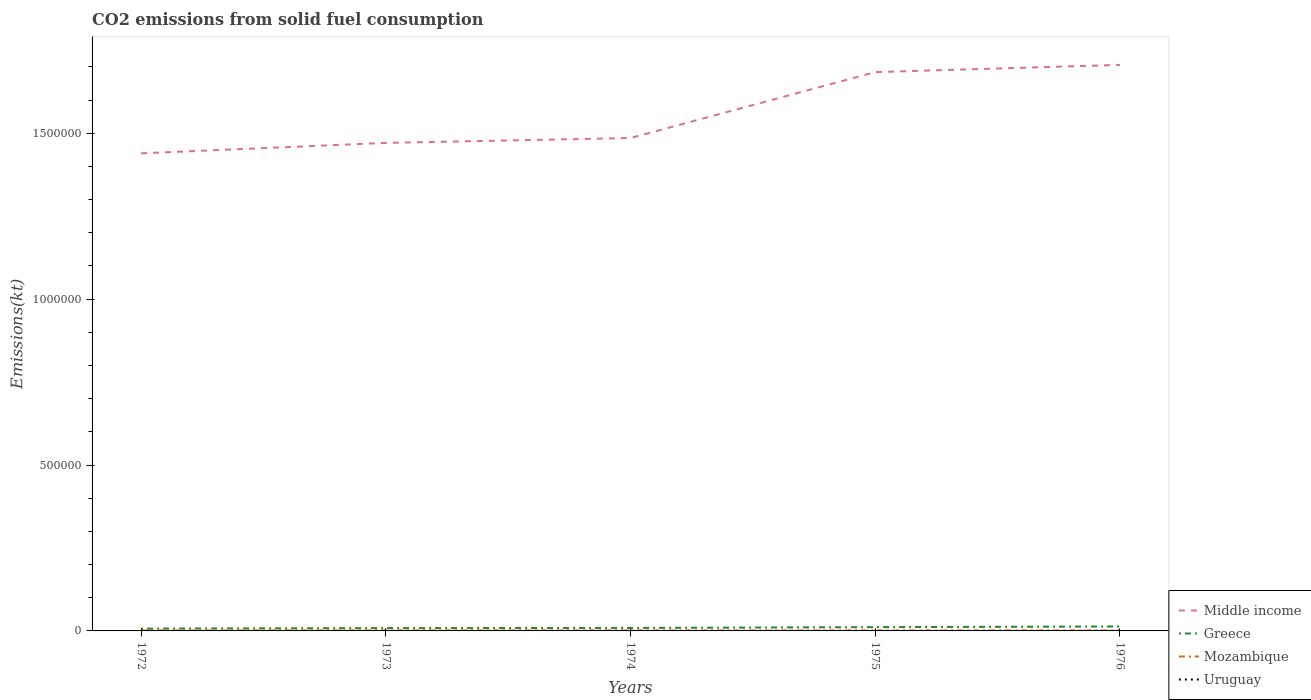Does the line corresponding to Middle income intersect with the line corresponding to Mozambique?
Give a very brief answer. No. Is the number of lines equal to the number of legend labels?
Give a very brief answer. Yes. Across all years, what is the maximum amount of CO2 emitted in Middle income?
Your answer should be very brief. 1.44e+06. In which year was the amount of CO2 emitted in Uruguay maximum?
Offer a very short reply. 1976. What is the total amount of CO2 emitted in Uruguay in the graph?
Ensure brevity in your answer.  11. What is the difference between the highest and the second highest amount of CO2 emitted in Mozambique?
Offer a terse response. 234.69. Is the amount of CO2 emitted in Middle income strictly greater than the amount of CO2 emitted in Uruguay over the years?
Ensure brevity in your answer.  No. How many lines are there?
Ensure brevity in your answer.  4. What is the difference between two consecutive major ticks on the Y-axis?
Give a very brief answer. 5.00e+05. Are the values on the major ticks of Y-axis written in scientific E-notation?
Provide a succinct answer. No. What is the title of the graph?
Keep it short and to the point. CO2 emissions from solid fuel consumption. Does "Denmark" appear as one of the legend labels in the graph?
Provide a short and direct response. No. What is the label or title of the X-axis?
Offer a terse response. Years. What is the label or title of the Y-axis?
Provide a short and direct response. Emissions(kt). What is the Emissions(kt) in Middle income in 1972?
Provide a succinct answer. 1.44e+06. What is the Emissions(kt) in Greece in 1972?
Your answer should be very brief. 6970.97. What is the Emissions(kt) in Mozambique in 1972?
Make the answer very short. 1426.46. What is the Emissions(kt) in Uruguay in 1972?
Your answer should be very brief. 88.01. What is the Emissions(kt) in Middle income in 1973?
Offer a terse response. 1.47e+06. What is the Emissions(kt) of Greece in 1973?
Offer a very short reply. 8500.11. What is the Emissions(kt) in Mozambique in 1973?
Provide a succinct answer. 1558.47. What is the Emissions(kt) of Uruguay in 1973?
Your answer should be very brief. 73.34. What is the Emissions(kt) in Middle income in 1974?
Give a very brief answer. 1.49e+06. What is the Emissions(kt) of Greece in 1974?
Your answer should be compact. 8998.82. What is the Emissions(kt) in Mozambique in 1974?
Keep it short and to the point. 1496.14. What is the Emissions(kt) in Uruguay in 1974?
Your response must be concise. 77.01. What is the Emissions(kt) in Middle income in 1975?
Offer a very short reply. 1.68e+06. What is the Emissions(kt) in Greece in 1975?
Your answer should be very brief. 1.14e+04. What is the Emissions(kt) in Mozambique in 1975?
Give a very brief answer. 1371.46. What is the Emissions(kt) in Uruguay in 1975?
Your answer should be compact. 77.01. What is the Emissions(kt) of Middle income in 1976?
Give a very brief answer. 1.71e+06. What is the Emissions(kt) of Greece in 1976?
Provide a short and direct response. 1.34e+04. What is the Emissions(kt) of Mozambique in 1976?
Your response must be concise. 1323.79. What is the Emissions(kt) in Uruguay in 1976?
Offer a very short reply. 69.67. Across all years, what is the maximum Emissions(kt) in Middle income?
Your answer should be very brief. 1.71e+06. Across all years, what is the maximum Emissions(kt) of Greece?
Provide a succinct answer. 1.34e+04. Across all years, what is the maximum Emissions(kt) of Mozambique?
Provide a succinct answer. 1558.47. Across all years, what is the maximum Emissions(kt) in Uruguay?
Give a very brief answer. 88.01. Across all years, what is the minimum Emissions(kt) in Middle income?
Offer a very short reply. 1.44e+06. Across all years, what is the minimum Emissions(kt) of Greece?
Keep it short and to the point. 6970.97. Across all years, what is the minimum Emissions(kt) in Mozambique?
Ensure brevity in your answer.  1323.79. Across all years, what is the minimum Emissions(kt) of Uruguay?
Your answer should be very brief. 69.67. What is the total Emissions(kt) in Middle income in the graph?
Your response must be concise. 7.79e+06. What is the total Emissions(kt) in Greece in the graph?
Your response must be concise. 4.92e+04. What is the total Emissions(kt) in Mozambique in the graph?
Make the answer very short. 7176.32. What is the total Emissions(kt) of Uruguay in the graph?
Provide a succinct answer. 385.04. What is the difference between the Emissions(kt) in Middle income in 1972 and that in 1973?
Ensure brevity in your answer.  -3.15e+04. What is the difference between the Emissions(kt) of Greece in 1972 and that in 1973?
Make the answer very short. -1529.14. What is the difference between the Emissions(kt) of Mozambique in 1972 and that in 1973?
Offer a very short reply. -132.01. What is the difference between the Emissions(kt) in Uruguay in 1972 and that in 1973?
Offer a terse response. 14.67. What is the difference between the Emissions(kt) of Middle income in 1972 and that in 1974?
Your answer should be compact. -4.62e+04. What is the difference between the Emissions(kt) of Greece in 1972 and that in 1974?
Give a very brief answer. -2027.85. What is the difference between the Emissions(kt) of Mozambique in 1972 and that in 1974?
Keep it short and to the point. -69.67. What is the difference between the Emissions(kt) in Uruguay in 1972 and that in 1974?
Offer a very short reply. 11. What is the difference between the Emissions(kt) in Middle income in 1972 and that in 1975?
Keep it short and to the point. -2.45e+05. What is the difference between the Emissions(kt) of Greece in 1972 and that in 1975?
Your response must be concise. -4393.07. What is the difference between the Emissions(kt) of Mozambique in 1972 and that in 1975?
Keep it short and to the point. 55.01. What is the difference between the Emissions(kt) of Uruguay in 1972 and that in 1975?
Your answer should be very brief. 11. What is the difference between the Emissions(kt) in Middle income in 1972 and that in 1976?
Give a very brief answer. -2.67e+05. What is the difference between the Emissions(kt) in Greece in 1972 and that in 1976?
Offer a very short reply. -6442.92. What is the difference between the Emissions(kt) in Mozambique in 1972 and that in 1976?
Give a very brief answer. 102.68. What is the difference between the Emissions(kt) of Uruguay in 1972 and that in 1976?
Provide a short and direct response. 18.34. What is the difference between the Emissions(kt) in Middle income in 1973 and that in 1974?
Give a very brief answer. -1.47e+04. What is the difference between the Emissions(kt) of Greece in 1973 and that in 1974?
Your answer should be compact. -498.71. What is the difference between the Emissions(kt) in Mozambique in 1973 and that in 1974?
Make the answer very short. 62.34. What is the difference between the Emissions(kt) in Uruguay in 1973 and that in 1974?
Make the answer very short. -3.67. What is the difference between the Emissions(kt) of Middle income in 1973 and that in 1975?
Keep it short and to the point. -2.13e+05. What is the difference between the Emissions(kt) of Greece in 1973 and that in 1975?
Your answer should be compact. -2863.93. What is the difference between the Emissions(kt) in Mozambique in 1973 and that in 1975?
Ensure brevity in your answer.  187.02. What is the difference between the Emissions(kt) in Uruguay in 1973 and that in 1975?
Your answer should be compact. -3.67. What is the difference between the Emissions(kt) of Middle income in 1973 and that in 1976?
Your answer should be compact. -2.35e+05. What is the difference between the Emissions(kt) in Greece in 1973 and that in 1976?
Provide a short and direct response. -4913.78. What is the difference between the Emissions(kt) of Mozambique in 1973 and that in 1976?
Your answer should be compact. 234.69. What is the difference between the Emissions(kt) of Uruguay in 1973 and that in 1976?
Offer a very short reply. 3.67. What is the difference between the Emissions(kt) of Middle income in 1974 and that in 1975?
Make the answer very short. -1.99e+05. What is the difference between the Emissions(kt) in Greece in 1974 and that in 1975?
Provide a short and direct response. -2365.22. What is the difference between the Emissions(kt) in Mozambique in 1974 and that in 1975?
Provide a succinct answer. 124.68. What is the difference between the Emissions(kt) of Uruguay in 1974 and that in 1975?
Keep it short and to the point. 0. What is the difference between the Emissions(kt) in Middle income in 1974 and that in 1976?
Your response must be concise. -2.20e+05. What is the difference between the Emissions(kt) of Greece in 1974 and that in 1976?
Make the answer very short. -4415.07. What is the difference between the Emissions(kt) of Mozambique in 1974 and that in 1976?
Provide a short and direct response. 172.35. What is the difference between the Emissions(kt) in Uruguay in 1974 and that in 1976?
Offer a very short reply. 7.33. What is the difference between the Emissions(kt) in Middle income in 1975 and that in 1976?
Ensure brevity in your answer.  -2.18e+04. What is the difference between the Emissions(kt) of Greece in 1975 and that in 1976?
Your answer should be compact. -2049.85. What is the difference between the Emissions(kt) of Mozambique in 1975 and that in 1976?
Offer a terse response. 47.67. What is the difference between the Emissions(kt) of Uruguay in 1975 and that in 1976?
Your answer should be very brief. 7.33. What is the difference between the Emissions(kt) of Middle income in 1972 and the Emissions(kt) of Greece in 1973?
Give a very brief answer. 1.43e+06. What is the difference between the Emissions(kt) of Middle income in 1972 and the Emissions(kt) of Mozambique in 1973?
Offer a very short reply. 1.44e+06. What is the difference between the Emissions(kt) in Middle income in 1972 and the Emissions(kt) in Uruguay in 1973?
Ensure brevity in your answer.  1.44e+06. What is the difference between the Emissions(kt) of Greece in 1972 and the Emissions(kt) of Mozambique in 1973?
Make the answer very short. 5412.49. What is the difference between the Emissions(kt) in Greece in 1972 and the Emissions(kt) in Uruguay in 1973?
Offer a terse response. 6897.63. What is the difference between the Emissions(kt) of Mozambique in 1972 and the Emissions(kt) of Uruguay in 1973?
Your response must be concise. 1353.12. What is the difference between the Emissions(kt) in Middle income in 1972 and the Emissions(kt) in Greece in 1974?
Provide a succinct answer. 1.43e+06. What is the difference between the Emissions(kt) in Middle income in 1972 and the Emissions(kt) in Mozambique in 1974?
Provide a succinct answer. 1.44e+06. What is the difference between the Emissions(kt) of Middle income in 1972 and the Emissions(kt) of Uruguay in 1974?
Give a very brief answer. 1.44e+06. What is the difference between the Emissions(kt) in Greece in 1972 and the Emissions(kt) in Mozambique in 1974?
Your answer should be very brief. 5474.83. What is the difference between the Emissions(kt) in Greece in 1972 and the Emissions(kt) in Uruguay in 1974?
Make the answer very short. 6893.96. What is the difference between the Emissions(kt) of Mozambique in 1972 and the Emissions(kt) of Uruguay in 1974?
Keep it short and to the point. 1349.46. What is the difference between the Emissions(kt) of Middle income in 1972 and the Emissions(kt) of Greece in 1975?
Ensure brevity in your answer.  1.43e+06. What is the difference between the Emissions(kt) of Middle income in 1972 and the Emissions(kt) of Mozambique in 1975?
Your answer should be very brief. 1.44e+06. What is the difference between the Emissions(kt) in Middle income in 1972 and the Emissions(kt) in Uruguay in 1975?
Offer a very short reply. 1.44e+06. What is the difference between the Emissions(kt) in Greece in 1972 and the Emissions(kt) in Mozambique in 1975?
Ensure brevity in your answer.  5599.51. What is the difference between the Emissions(kt) of Greece in 1972 and the Emissions(kt) of Uruguay in 1975?
Your answer should be very brief. 6893.96. What is the difference between the Emissions(kt) of Mozambique in 1972 and the Emissions(kt) of Uruguay in 1975?
Give a very brief answer. 1349.46. What is the difference between the Emissions(kt) in Middle income in 1972 and the Emissions(kt) in Greece in 1976?
Offer a very short reply. 1.43e+06. What is the difference between the Emissions(kt) of Middle income in 1972 and the Emissions(kt) of Mozambique in 1976?
Provide a short and direct response. 1.44e+06. What is the difference between the Emissions(kt) in Middle income in 1972 and the Emissions(kt) in Uruguay in 1976?
Your answer should be very brief. 1.44e+06. What is the difference between the Emissions(kt) of Greece in 1972 and the Emissions(kt) of Mozambique in 1976?
Make the answer very short. 5647.18. What is the difference between the Emissions(kt) of Greece in 1972 and the Emissions(kt) of Uruguay in 1976?
Make the answer very short. 6901.29. What is the difference between the Emissions(kt) of Mozambique in 1972 and the Emissions(kt) of Uruguay in 1976?
Your response must be concise. 1356.79. What is the difference between the Emissions(kt) of Middle income in 1973 and the Emissions(kt) of Greece in 1974?
Offer a very short reply. 1.46e+06. What is the difference between the Emissions(kt) in Middle income in 1973 and the Emissions(kt) in Mozambique in 1974?
Keep it short and to the point. 1.47e+06. What is the difference between the Emissions(kt) of Middle income in 1973 and the Emissions(kt) of Uruguay in 1974?
Your answer should be very brief. 1.47e+06. What is the difference between the Emissions(kt) of Greece in 1973 and the Emissions(kt) of Mozambique in 1974?
Your response must be concise. 7003.97. What is the difference between the Emissions(kt) in Greece in 1973 and the Emissions(kt) in Uruguay in 1974?
Your answer should be compact. 8423.1. What is the difference between the Emissions(kt) of Mozambique in 1973 and the Emissions(kt) of Uruguay in 1974?
Give a very brief answer. 1481.47. What is the difference between the Emissions(kt) in Middle income in 1973 and the Emissions(kt) in Greece in 1975?
Provide a succinct answer. 1.46e+06. What is the difference between the Emissions(kt) of Middle income in 1973 and the Emissions(kt) of Mozambique in 1975?
Provide a short and direct response. 1.47e+06. What is the difference between the Emissions(kt) of Middle income in 1973 and the Emissions(kt) of Uruguay in 1975?
Your answer should be very brief. 1.47e+06. What is the difference between the Emissions(kt) in Greece in 1973 and the Emissions(kt) in Mozambique in 1975?
Provide a short and direct response. 7128.65. What is the difference between the Emissions(kt) of Greece in 1973 and the Emissions(kt) of Uruguay in 1975?
Give a very brief answer. 8423.1. What is the difference between the Emissions(kt) of Mozambique in 1973 and the Emissions(kt) of Uruguay in 1975?
Offer a very short reply. 1481.47. What is the difference between the Emissions(kt) in Middle income in 1973 and the Emissions(kt) in Greece in 1976?
Your answer should be compact. 1.46e+06. What is the difference between the Emissions(kt) of Middle income in 1973 and the Emissions(kt) of Mozambique in 1976?
Offer a very short reply. 1.47e+06. What is the difference between the Emissions(kt) of Middle income in 1973 and the Emissions(kt) of Uruguay in 1976?
Provide a succinct answer. 1.47e+06. What is the difference between the Emissions(kt) in Greece in 1973 and the Emissions(kt) in Mozambique in 1976?
Offer a very short reply. 7176.32. What is the difference between the Emissions(kt) in Greece in 1973 and the Emissions(kt) in Uruguay in 1976?
Offer a terse response. 8430.43. What is the difference between the Emissions(kt) of Mozambique in 1973 and the Emissions(kt) of Uruguay in 1976?
Give a very brief answer. 1488.8. What is the difference between the Emissions(kt) of Middle income in 1974 and the Emissions(kt) of Greece in 1975?
Keep it short and to the point. 1.47e+06. What is the difference between the Emissions(kt) in Middle income in 1974 and the Emissions(kt) in Mozambique in 1975?
Offer a very short reply. 1.48e+06. What is the difference between the Emissions(kt) of Middle income in 1974 and the Emissions(kt) of Uruguay in 1975?
Offer a terse response. 1.49e+06. What is the difference between the Emissions(kt) of Greece in 1974 and the Emissions(kt) of Mozambique in 1975?
Offer a terse response. 7627.36. What is the difference between the Emissions(kt) of Greece in 1974 and the Emissions(kt) of Uruguay in 1975?
Give a very brief answer. 8921.81. What is the difference between the Emissions(kt) of Mozambique in 1974 and the Emissions(kt) of Uruguay in 1975?
Make the answer very short. 1419.13. What is the difference between the Emissions(kt) of Middle income in 1974 and the Emissions(kt) of Greece in 1976?
Your response must be concise. 1.47e+06. What is the difference between the Emissions(kt) in Middle income in 1974 and the Emissions(kt) in Mozambique in 1976?
Provide a succinct answer. 1.48e+06. What is the difference between the Emissions(kt) in Middle income in 1974 and the Emissions(kt) in Uruguay in 1976?
Offer a very short reply. 1.49e+06. What is the difference between the Emissions(kt) in Greece in 1974 and the Emissions(kt) in Mozambique in 1976?
Offer a very short reply. 7675.03. What is the difference between the Emissions(kt) of Greece in 1974 and the Emissions(kt) of Uruguay in 1976?
Keep it short and to the point. 8929.15. What is the difference between the Emissions(kt) in Mozambique in 1974 and the Emissions(kt) in Uruguay in 1976?
Your answer should be compact. 1426.46. What is the difference between the Emissions(kt) in Middle income in 1975 and the Emissions(kt) in Greece in 1976?
Your answer should be very brief. 1.67e+06. What is the difference between the Emissions(kt) in Middle income in 1975 and the Emissions(kt) in Mozambique in 1976?
Give a very brief answer. 1.68e+06. What is the difference between the Emissions(kt) in Middle income in 1975 and the Emissions(kt) in Uruguay in 1976?
Provide a short and direct response. 1.68e+06. What is the difference between the Emissions(kt) in Greece in 1975 and the Emissions(kt) in Mozambique in 1976?
Provide a succinct answer. 1.00e+04. What is the difference between the Emissions(kt) in Greece in 1975 and the Emissions(kt) in Uruguay in 1976?
Offer a very short reply. 1.13e+04. What is the difference between the Emissions(kt) of Mozambique in 1975 and the Emissions(kt) of Uruguay in 1976?
Your response must be concise. 1301.79. What is the average Emissions(kt) in Middle income per year?
Your answer should be compact. 1.56e+06. What is the average Emissions(kt) in Greece per year?
Ensure brevity in your answer.  9849.56. What is the average Emissions(kt) of Mozambique per year?
Provide a short and direct response. 1435.26. What is the average Emissions(kt) in Uruguay per year?
Your answer should be compact. 77.01. In the year 1972, what is the difference between the Emissions(kt) of Middle income and Emissions(kt) of Greece?
Make the answer very short. 1.43e+06. In the year 1972, what is the difference between the Emissions(kt) of Middle income and Emissions(kt) of Mozambique?
Your answer should be compact. 1.44e+06. In the year 1972, what is the difference between the Emissions(kt) in Middle income and Emissions(kt) in Uruguay?
Offer a terse response. 1.44e+06. In the year 1972, what is the difference between the Emissions(kt) in Greece and Emissions(kt) in Mozambique?
Your response must be concise. 5544.5. In the year 1972, what is the difference between the Emissions(kt) in Greece and Emissions(kt) in Uruguay?
Offer a terse response. 6882.96. In the year 1972, what is the difference between the Emissions(kt) in Mozambique and Emissions(kt) in Uruguay?
Your answer should be very brief. 1338.45. In the year 1973, what is the difference between the Emissions(kt) in Middle income and Emissions(kt) in Greece?
Provide a short and direct response. 1.46e+06. In the year 1973, what is the difference between the Emissions(kt) in Middle income and Emissions(kt) in Mozambique?
Keep it short and to the point. 1.47e+06. In the year 1973, what is the difference between the Emissions(kt) in Middle income and Emissions(kt) in Uruguay?
Offer a terse response. 1.47e+06. In the year 1973, what is the difference between the Emissions(kt) of Greece and Emissions(kt) of Mozambique?
Your response must be concise. 6941.63. In the year 1973, what is the difference between the Emissions(kt) in Greece and Emissions(kt) in Uruguay?
Provide a short and direct response. 8426.77. In the year 1973, what is the difference between the Emissions(kt) in Mozambique and Emissions(kt) in Uruguay?
Your answer should be very brief. 1485.13. In the year 1974, what is the difference between the Emissions(kt) in Middle income and Emissions(kt) in Greece?
Your answer should be compact. 1.48e+06. In the year 1974, what is the difference between the Emissions(kt) in Middle income and Emissions(kt) in Mozambique?
Your answer should be compact. 1.48e+06. In the year 1974, what is the difference between the Emissions(kt) in Middle income and Emissions(kt) in Uruguay?
Offer a very short reply. 1.49e+06. In the year 1974, what is the difference between the Emissions(kt) of Greece and Emissions(kt) of Mozambique?
Give a very brief answer. 7502.68. In the year 1974, what is the difference between the Emissions(kt) of Greece and Emissions(kt) of Uruguay?
Offer a very short reply. 8921.81. In the year 1974, what is the difference between the Emissions(kt) of Mozambique and Emissions(kt) of Uruguay?
Your answer should be compact. 1419.13. In the year 1975, what is the difference between the Emissions(kt) of Middle income and Emissions(kt) of Greece?
Give a very brief answer. 1.67e+06. In the year 1975, what is the difference between the Emissions(kt) of Middle income and Emissions(kt) of Mozambique?
Ensure brevity in your answer.  1.68e+06. In the year 1975, what is the difference between the Emissions(kt) of Middle income and Emissions(kt) of Uruguay?
Provide a succinct answer. 1.68e+06. In the year 1975, what is the difference between the Emissions(kt) of Greece and Emissions(kt) of Mozambique?
Give a very brief answer. 9992.58. In the year 1975, what is the difference between the Emissions(kt) in Greece and Emissions(kt) in Uruguay?
Your answer should be compact. 1.13e+04. In the year 1975, what is the difference between the Emissions(kt) of Mozambique and Emissions(kt) of Uruguay?
Provide a short and direct response. 1294.45. In the year 1976, what is the difference between the Emissions(kt) of Middle income and Emissions(kt) of Greece?
Offer a terse response. 1.69e+06. In the year 1976, what is the difference between the Emissions(kt) of Middle income and Emissions(kt) of Mozambique?
Give a very brief answer. 1.70e+06. In the year 1976, what is the difference between the Emissions(kt) of Middle income and Emissions(kt) of Uruguay?
Your answer should be very brief. 1.71e+06. In the year 1976, what is the difference between the Emissions(kt) of Greece and Emissions(kt) of Mozambique?
Give a very brief answer. 1.21e+04. In the year 1976, what is the difference between the Emissions(kt) in Greece and Emissions(kt) in Uruguay?
Provide a succinct answer. 1.33e+04. In the year 1976, what is the difference between the Emissions(kt) in Mozambique and Emissions(kt) in Uruguay?
Give a very brief answer. 1254.11. What is the ratio of the Emissions(kt) of Middle income in 1972 to that in 1973?
Make the answer very short. 0.98. What is the ratio of the Emissions(kt) of Greece in 1972 to that in 1973?
Ensure brevity in your answer.  0.82. What is the ratio of the Emissions(kt) in Mozambique in 1972 to that in 1973?
Provide a succinct answer. 0.92. What is the ratio of the Emissions(kt) in Uruguay in 1972 to that in 1973?
Your answer should be very brief. 1.2. What is the ratio of the Emissions(kt) of Middle income in 1972 to that in 1974?
Provide a succinct answer. 0.97. What is the ratio of the Emissions(kt) in Greece in 1972 to that in 1974?
Give a very brief answer. 0.77. What is the ratio of the Emissions(kt) of Mozambique in 1972 to that in 1974?
Your response must be concise. 0.95. What is the ratio of the Emissions(kt) of Middle income in 1972 to that in 1975?
Offer a terse response. 0.85. What is the ratio of the Emissions(kt) in Greece in 1972 to that in 1975?
Provide a succinct answer. 0.61. What is the ratio of the Emissions(kt) of Mozambique in 1972 to that in 1975?
Keep it short and to the point. 1.04. What is the ratio of the Emissions(kt) of Middle income in 1972 to that in 1976?
Provide a short and direct response. 0.84. What is the ratio of the Emissions(kt) in Greece in 1972 to that in 1976?
Your answer should be compact. 0.52. What is the ratio of the Emissions(kt) in Mozambique in 1972 to that in 1976?
Give a very brief answer. 1.08. What is the ratio of the Emissions(kt) of Uruguay in 1972 to that in 1976?
Your response must be concise. 1.26. What is the ratio of the Emissions(kt) in Middle income in 1973 to that in 1974?
Give a very brief answer. 0.99. What is the ratio of the Emissions(kt) in Greece in 1973 to that in 1974?
Your answer should be very brief. 0.94. What is the ratio of the Emissions(kt) of Mozambique in 1973 to that in 1974?
Offer a terse response. 1.04. What is the ratio of the Emissions(kt) of Uruguay in 1973 to that in 1974?
Your response must be concise. 0.95. What is the ratio of the Emissions(kt) of Middle income in 1973 to that in 1975?
Keep it short and to the point. 0.87. What is the ratio of the Emissions(kt) in Greece in 1973 to that in 1975?
Provide a short and direct response. 0.75. What is the ratio of the Emissions(kt) in Mozambique in 1973 to that in 1975?
Keep it short and to the point. 1.14. What is the ratio of the Emissions(kt) of Middle income in 1973 to that in 1976?
Your answer should be very brief. 0.86. What is the ratio of the Emissions(kt) of Greece in 1973 to that in 1976?
Keep it short and to the point. 0.63. What is the ratio of the Emissions(kt) of Mozambique in 1973 to that in 1976?
Your answer should be very brief. 1.18. What is the ratio of the Emissions(kt) of Uruguay in 1973 to that in 1976?
Offer a very short reply. 1.05. What is the ratio of the Emissions(kt) of Middle income in 1974 to that in 1975?
Provide a short and direct response. 0.88. What is the ratio of the Emissions(kt) of Greece in 1974 to that in 1975?
Your answer should be very brief. 0.79. What is the ratio of the Emissions(kt) in Middle income in 1974 to that in 1976?
Ensure brevity in your answer.  0.87. What is the ratio of the Emissions(kt) of Greece in 1974 to that in 1976?
Ensure brevity in your answer.  0.67. What is the ratio of the Emissions(kt) in Mozambique in 1974 to that in 1976?
Your answer should be compact. 1.13. What is the ratio of the Emissions(kt) of Uruguay in 1974 to that in 1976?
Keep it short and to the point. 1.11. What is the ratio of the Emissions(kt) of Middle income in 1975 to that in 1976?
Ensure brevity in your answer.  0.99. What is the ratio of the Emissions(kt) in Greece in 1975 to that in 1976?
Your response must be concise. 0.85. What is the ratio of the Emissions(kt) of Mozambique in 1975 to that in 1976?
Offer a terse response. 1.04. What is the ratio of the Emissions(kt) in Uruguay in 1975 to that in 1976?
Make the answer very short. 1.11. What is the difference between the highest and the second highest Emissions(kt) in Middle income?
Your response must be concise. 2.18e+04. What is the difference between the highest and the second highest Emissions(kt) in Greece?
Give a very brief answer. 2049.85. What is the difference between the highest and the second highest Emissions(kt) of Mozambique?
Ensure brevity in your answer.  62.34. What is the difference between the highest and the second highest Emissions(kt) in Uruguay?
Offer a very short reply. 11. What is the difference between the highest and the lowest Emissions(kt) in Middle income?
Ensure brevity in your answer.  2.67e+05. What is the difference between the highest and the lowest Emissions(kt) in Greece?
Your response must be concise. 6442.92. What is the difference between the highest and the lowest Emissions(kt) of Mozambique?
Offer a terse response. 234.69. What is the difference between the highest and the lowest Emissions(kt) of Uruguay?
Your answer should be very brief. 18.34. 